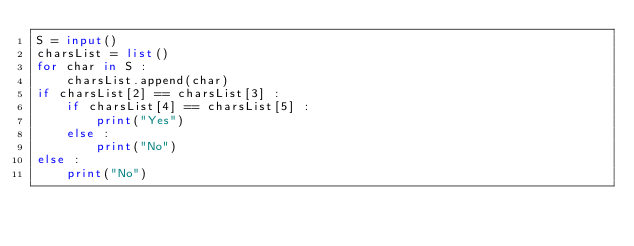Convert code to text. <code><loc_0><loc_0><loc_500><loc_500><_Python_>S = input()
charsList = list()
for char in S :
    charsList.append(char)
if charsList[2] == charsList[3] :
    if charsList[4] == charsList[5] :
        print("Yes")
    else :
        print("No")
else :
    print("No")</code> 